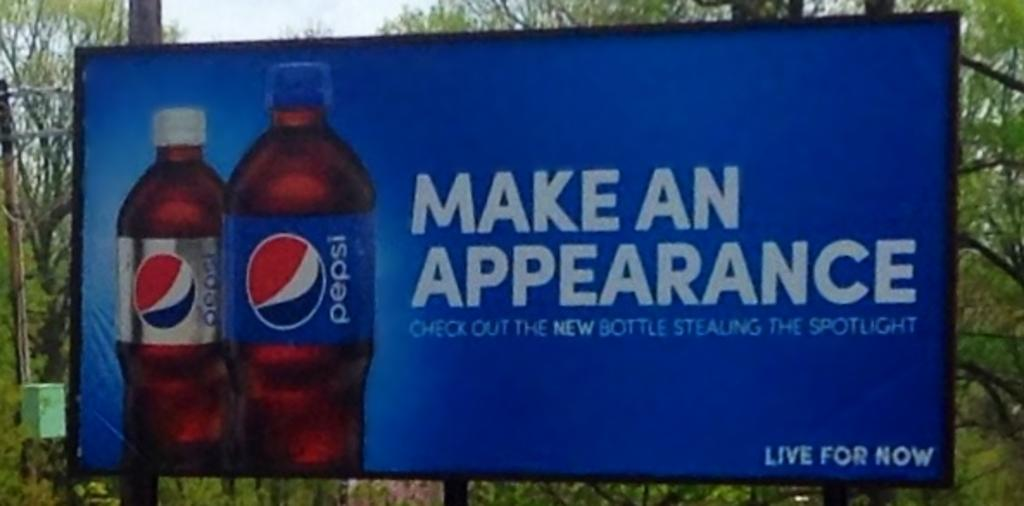<image>
Create a compact narrative representing the image presented. A large advertising board shows two pepsi bottles and the slogan make an appearance. 